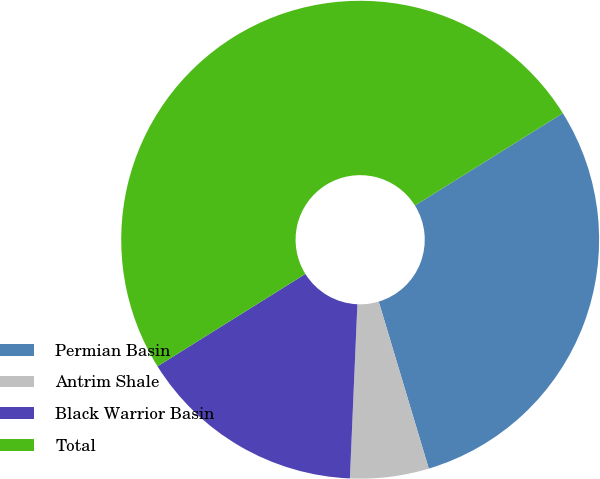<chart> <loc_0><loc_0><loc_500><loc_500><pie_chart><fcel>Permian Basin<fcel>Antrim Shale<fcel>Black Warrior Basin<fcel>Total<nl><fcel>29.25%<fcel>5.32%<fcel>15.43%<fcel>50.0%<nl></chart> 